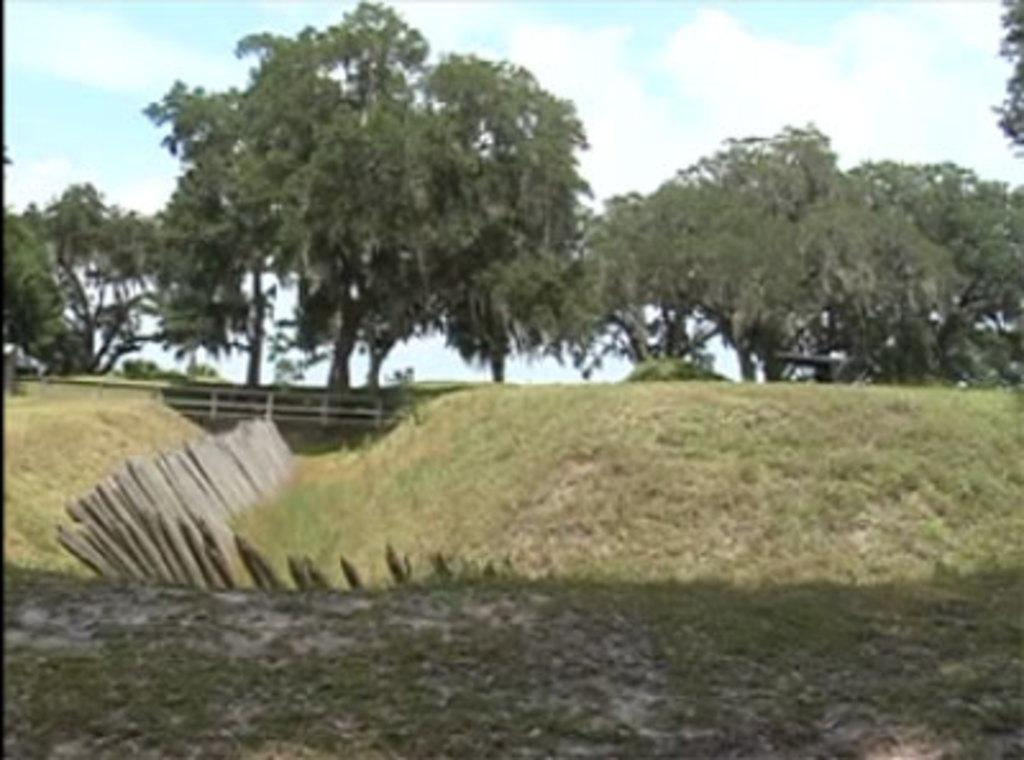What type of vegetation can be seen in the image? There are many trees in the image. What else can be seen on the ground in the image? There is grass in the image. What structure is present in the image? There is a bridge in the image. What material are the sticks visible in the image made of? The wooden sticks are made of wood. What is visible at the top of the image? The sky is visible at the top of the image. Can you see any jellyfish swimming in the grass in the image? There are no jellyfish present in the image; it features trees, grass, a bridge, wooden sticks, and the sky. How does the hand interact with the wooden sticks in the image? There is no hand visible in the image; it only shows trees, grass, a bridge, wooden sticks, and the sky. 